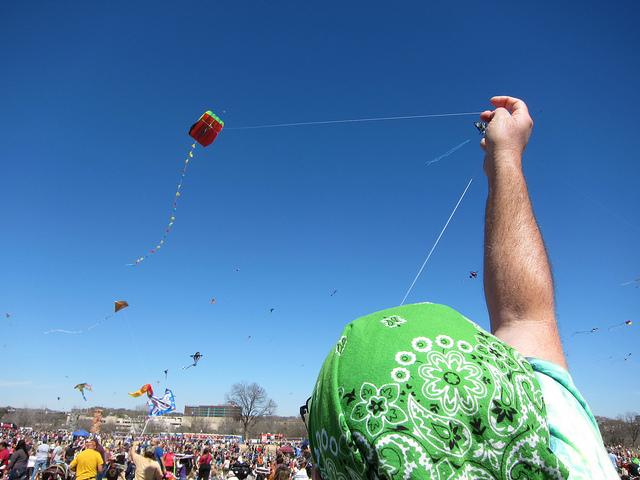What are the people flying?
Concise answer only. Kites. Are cloud visible?
Write a very short answer. No. What color is the man's bandana?
Be succinct. Green. 